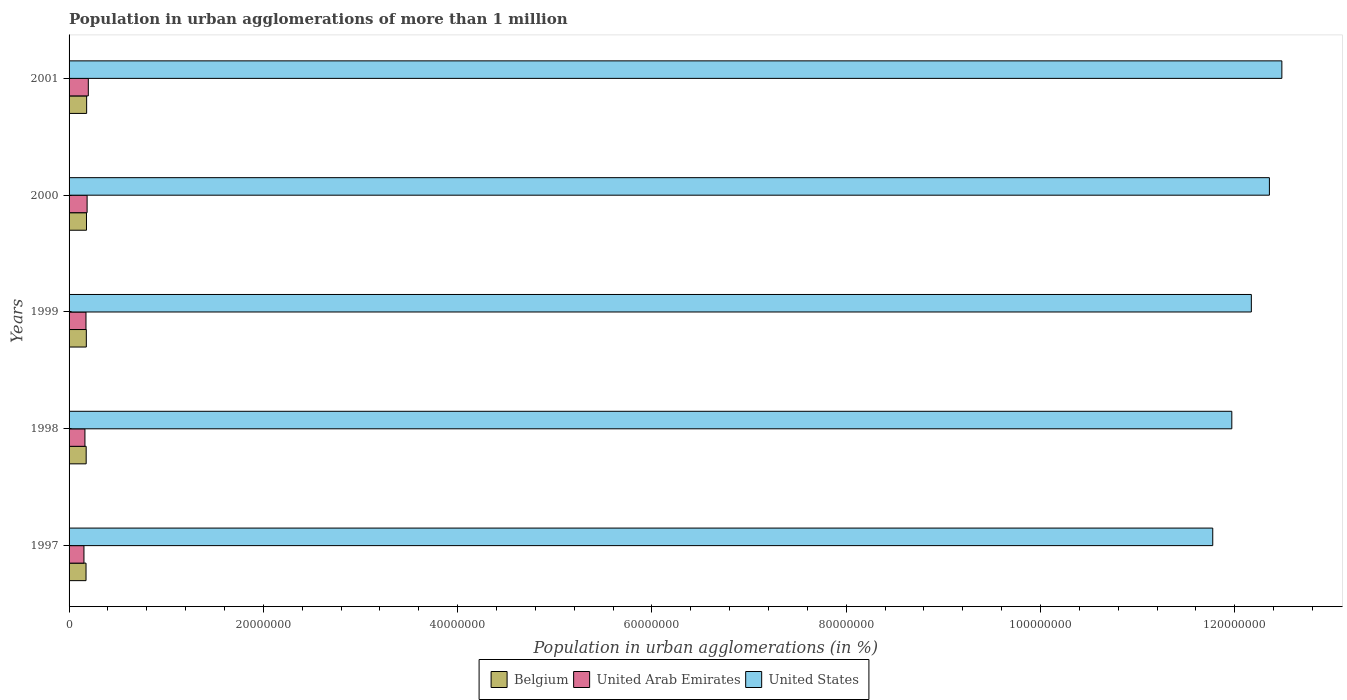How many different coloured bars are there?
Provide a succinct answer. 3. How many groups of bars are there?
Provide a short and direct response. 5. How many bars are there on the 2nd tick from the bottom?
Your answer should be very brief. 3. What is the label of the 1st group of bars from the top?
Keep it short and to the point. 2001. In how many cases, is the number of bars for a given year not equal to the number of legend labels?
Offer a terse response. 0. What is the population in urban agglomerations in Belgium in 1999?
Offer a terse response. 1.78e+06. Across all years, what is the maximum population in urban agglomerations in United States?
Make the answer very short. 1.25e+08. Across all years, what is the minimum population in urban agglomerations in United Arab Emirates?
Give a very brief answer. 1.53e+06. In which year was the population in urban agglomerations in Belgium minimum?
Your answer should be very brief. 1997. What is the total population in urban agglomerations in Belgium in the graph?
Offer a very short reply. 8.88e+06. What is the difference between the population in urban agglomerations in United Arab Emirates in 1998 and that in 2000?
Your answer should be compact. -2.24e+05. What is the difference between the population in urban agglomerations in United Arab Emirates in 2000 and the population in urban agglomerations in United States in 1999?
Your answer should be very brief. -1.20e+08. What is the average population in urban agglomerations in Belgium per year?
Your answer should be very brief. 1.78e+06. In the year 1999, what is the difference between the population in urban agglomerations in United Arab Emirates and population in urban agglomerations in Belgium?
Give a very brief answer. -3.55e+04. What is the ratio of the population in urban agglomerations in Belgium in 1998 to that in 2000?
Give a very brief answer. 0.98. Is the population in urban agglomerations in Belgium in 1997 less than that in 2000?
Make the answer very short. Yes. Is the difference between the population in urban agglomerations in United Arab Emirates in 1997 and 1998 greater than the difference between the population in urban agglomerations in Belgium in 1997 and 1998?
Offer a very short reply. No. What is the difference between the highest and the second highest population in urban agglomerations in United Arab Emirates?
Offer a very short reply. 1.23e+05. What is the difference between the highest and the lowest population in urban agglomerations in United States?
Your answer should be very brief. 7.11e+06. How many bars are there?
Ensure brevity in your answer.  15. What is the difference between two consecutive major ticks on the X-axis?
Offer a very short reply. 2.00e+07. Does the graph contain any zero values?
Your answer should be compact. No. Does the graph contain grids?
Provide a succinct answer. No. Where does the legend appear in the graph?
Your response must be concise. Bottom center. How are the legend labels stacked?
Keep it short and to the point. Horizontal. What is the title of the graph?
Keep it short and to the point. Population in urban agglomerations of more than 1 million. Does "Nepal" appear as one of the legend labels in the graph?
Your answer should be very brief. No. What is the label or title of the X-axis?
Provide a short and direct response. Population in urban agglomerations (in %). What is the label or title of the Y-axis?
Your answer should be very brief. Years. What is the Population in urban agglomerations (in %) in Belgium in 1997?
Ensure brevity in your answer.  1.75e+06. What is the Population in urban agglomerations (in %) in United Arab Emirates in 1997?
Offer a very short reply. 1.53e+06. What is the Population in urban agglomerations (in %) of United States in 1997?
Provide a short and direct response. 1.18e+08. What is the Population in urban agglomerations (in %) of Belgium in 1998?
Your answer should be compact. 1.76e+06. What is the Population in urban agglomerations (in %) of United Arab Emirates in 1998?
Provide a succinct answer. 1.63e+06. What is the Population in urban agglomerations (in %) in United States in 1998?
Offer a very short reply. 1.20e+08. What is the Population in urban agglomerations (in %) of Belgium in 1999?
Provide a succinct answer. 1.78e+06. What is the Population in urban agglomerations (in %) in United Arab Emirates in 1999?
Your response must be concise. 1.74e+06. What is the Population in urban agglomerations (in %) in United States in 1999?
Provide a short and direct response. 1.22e+08. What is the Population in urban agglomerations (in %) in Belgium in 2000?
Give a very brief answer. 1.79e+06. What is the Population in urban agglomerations (in %) of United Arab Emirates in 2000?
Provide a short and direct response. 1.86e+06. What is the Population in urban agglomerations (in %) of United States in 2000?
Keep it short and to the point. 1.24e+08. What is the Population in urban agglomerations (in %) of Belgium in 2001?
Your answer should be very brief. 1.81e+06. What is the Population in urban agglomerations (in %) in United Arab Emirates in 2001?
Your answer should be very brief. 1.98e+06. What is the Population in urban agglomerations (in %) of United States in 2001?
Your answer should be compact. 1.25e+08. Across all years, what is the maximum Population in urban agglomerations (in %) of Belgium?
Ensure brevity in your answer.  1.81e+06. Across all years, what is the maximum Population in urban agglomerations (in %) in United Arab Emirates?
Offer a very short reply. 1.98e+06. Across all years, what is the maximum Population in urban agglomerations (in %) in United States?
Your answer should be very brief. 1.25e+08. Across all years, what is the minimum Population in urban agglomerations (in %) of Belgium?
Your answer should be very brief. 1.75e+06. Across all years, what is the minimum Population in urban agglomerations (in %) of United Arab Emirates?
Your response must be concise. 1.53e+06. Across all years, what is the minimum Population in urban agglomerations (in %) in United States?
Provide a short and direct response. 1.18e+08. What is the total Population in urban agglomerations (in %) of Belgium in the graph?
Offer a very short reply. 8.88e+06. What is the total Population in urban agglomerations (in %) of United Arab Emirates in the graph?
Provide a short and direct response. 8.74e+06. What is the total Population in urban agglomerations (in %) of United States in the graph?
Provide a succinct answer. 6.08e+08. What is the difference between the Population in urban agglomerations (in %) in Belgium in 1997 and that in 1998?
Provide a succinct answer. -1.55e+04. What is the difference between the Population in urban agglomerations (in %) of United Arab Emirates in 1997 and that in 1998?
Your response must be concise. -1.01e+05. What is the difference between the Population in urban agglomerations (in %) in United States in 1997 and that in 1998?
Keep it short and to the point. -1.96e+06. What is the difference between the Population in urban agglomerations (in %) of Belgium in 1997 and that in 1999?
Offer a terse response. -3.11e+04. What is the difference between the Population in urban agglomerations (in %) in United Arab Emirates in 1997 and that in 1999?
Your response must be concise. -2.10e+05. What is the difference between the Population in urban agglomerations (in %) in United States in 1997 and that in 1999?
Offer a very short reply. -3.97e+06. What is the difference between the Population in urban agglomerations (in %) of Belgium in 1997 and that in 2000?
Give a very brief answer. -4.69e+04. What is the difference between the Population in urban agglomerations (in %) of United Arab Emirates in 1997 and that in 2000?
Offer a very short reply. -3.25e+05. What is the difference between the Population in urban agglomerations (in %) of United States in 1997 and that in 2000?
Provide a short and direct response. -5.83e+06. What is the difference between the Population in urban agglomerations (in %) of Belgium in 1997 and that in 2001?
Your response must be concise. -6.28e+04. What is the difference between the Population in urban agglomerations (in %) in United Arab Emirates in 1997 and that in 2001?
Make the answer very short. -4.49e+05. What is the difference between the Population in urban agglomerations (in %) in United States in 1997 and that in 2001?
Your answer should be compact. -7.11e+06. What is the difference between the Population in urban agglomerations (in %) in Belgium in 1998 and that in 1999?
Your answer should be very brief. -1.56e+04. What is the difference between the Population in urban agglomerations (in %) in United Arab Emirates in 1998 and that in 1999?
Give a very brief answer. -1.08e+05. What is the difference between the Population in urban agglomerations (in %) of United States in 1998 and that in 1999?
Make the answer very short. -2.01e+06. What is the difference between the Population in urban agglomerations (in %) of Belgium in 1998 and that in 2000?
Your answer should be compact. -3.14e+04. What is the difference between the Population in urban agglomerations (in %) in United Arab Emirates in 1998 and that in 2000?
Provide a short and direct response. -2.24e+05. What is the difference between the Population in urban agglomerations (in %) in United States in 1998 and that in 2000?
Your answer should be compact. -3.87e+06. What is the difference between the Population in urban agglomerations (in %) in Belgium in 1998 and that in 2001?
Offer a terse response. -4.73e+04. What is the difference between the Population in urban agglomerations (in %) of United Arab Emirates in 1998 and that in 2001?
Offer a very short reply. -3.47e+05. What is the difference between the Population in urban agglomerations (in %) of United States in 1998 and that in 2001?
Your answer should be compact. -5.15e+06. What is the difference between the Population in urban agglomerations (in %) in Belgium in 1999 and that in 2000?
Provide a short and direct response. -1.58e+04. What is the difference between the Population in urban agglomerations (in %) of United Arab Emirates in 1999 and that in 2000?
Make the answer very short. -1.16e+05. What is the difference between the Population in urban agglomerations (in %) in United States in 1999 and that in 2000?
Offer a terse response. -1.86e+06. What is the difference between the Population in urban agglomerations (in %) in Belgium in 1999 and that in 2001?
Your answer should be compact. -3.17e+04. What is the difference between the Population in urban agglomerations (in %) of United Arab Emirates in 1999 and that in 2001?
Keep it short and to the point. -2.39e+05. What is the difference between the Population in urban agglomerations (in %) in United States in 1999 and that in 2001?
Offer a terse response. -3.14e+06. What is the difference between the Population in urban agglomerations (in %) of Belgium in 2000 and that in 2001?
Keep it short and to the point. -1.59e+04. What is the difference between the Population in urban agglomerations (in %) in United Arab Emirates in 2000 and that in 2001?
Keep it short and to the point. -1.23e+05. What is the difference between the Population in urban agglomerations (in %) of United States in 2000 and that in 2001?
Offer a terse response. -1.28e+06. What is the difference between the Population in urban agglomerations (in %) of Belgium in 1997 and the Population in urban agglomerations (in %) of United Arab Emirates in 1998?
Make the answer very short. 1.13e+05. What is the difference between the Population in urban agglomerations (in %) of Belgium in 1997 and the Population in urban agglomerations (in %) of United States in 1998?
Your answer should be compact. -1.18e+08. What is the difference between the Population in urban agglomerations (in %) of United Arab Emirates in 1997 and the Population in urban agglomerations (in %) of United States in 1998?
Provide a succinct answer. -1.18e+08. What is the difference between the Population in urban agglomerations (in %) of Belgium in 1997 and the Population in urban agglomerations (in %) of United Arab Emirates in 1999?
Keep it short and to the point. 4359. What is the difference between the Population in urban agglomerations (in %) of Belgium in 1997 and the Population in urban agglomerations (in %) of United States in 1999?
Make the answer very short. -1.20e+08. What is the difference between the Population in urban agglomerations (in %) of United Arab Emirates in 1997 and the Population in urban agglomerations (in %) of United States in 1999?
Your answer should be very brief. -1.20e+08. What is the difference between the Population in urban agglomerations (in %) in Belgium in 1997 and the Population in urban agglomerations (in %) in United Arab Emirates in 2000?
Your answer should be compact. -1.11e+05. What is the difference between the Population in urban agglomerations (in %) of Belgium in 1997 and the Population in urban agglomerations (in %) of United States in 2000?
Provide a succinct answer. -1.22e+08. What is the difference between the Population in urban agglomerations (in %) in United Arab Emirates in 1997 and the Population in urban agglomerations (in %) in United States in 2000?
Your response must be concise. -1.22e+08. What is the difference between the Population in urban agglomerations (in %) in Belgium in 1997 and the Population in urban agglomerations (in %) in United Arab Emirates in 2001?
Give a very brief answer. -2.34e+05. What is the difference between the Population in urban agglomerations (in %) of Belgium in 1997 and the Population in urban agglomerations (in %) of United States in 2001?
Ensure brevity in your answer.  -1.23e+08. What is the difference between the Population in urban agglomerations (in %) in United Arab Emirates in 1997 and the Population in urban agglomerations (in %) in United States in 2001?
Make the answer very short. -1.23e+08. What is the difference between the Population in urban agglomerations (in %) of Belgium in 1998 and the Population in urban agglomerations (in %) of United Arab Emirates in 1999?
Keep it short and to the point. 1.99e+04. What is the difference between the Population in urban agglomerations (in %) of Belgium in 1998 and the Population in urban agglomerations (in %) of United States in 1999?
Keep it short and to the point. -1.20e+08. What is the difference between the Population in urban agglomerations (in %) of United Arab Emirates in 1998 and the Population in urban agglomerations (in %) of United States in 1999?
Ensure brevity in your answer.  -1.20e+08. What is the difference between the Population in urban agglomerations (in %) of Belgium in 1998 and the Population in urban agglomerations (in %) of United Arab Emirates in 2000?
Offer a very short reply. -9.58e+04. What is the difference between the Population in urban agglomerations (in %) in Belgium in 1998 and the Population in urban agglomerations (in %) in United States in 2000?
Your answer should be compact. -1.22e+08. What is the difference between the Population in urban agglomerations (in %) in United Arab Emirates in 1998 and the Population in urban agglomerations (in %) in United States in 2000?
Provide a succinct answer. -1.22e+08. What is the difference between the Population in urban agglomerations (in %) of Belgium in 1998 and the Population in urban agglomerations (in %) of United Arab Emirates in 2001?
Offer a very short reply. -2.19e+05. What is the difference between the Population in urban agglomerations (in %) in Belgium in 1998 and the Population in urban agglomerations (in %) in United States in 2001?
Provide a succinct answer. -1.23e+08. What is the difference between the Population in urban agglomerations (in %) of United Arab Emirates in 1998 and the Population in urban agglomerations (in %) of United States in 2001?
Provide a succinct answer. -1.23e+08. What is the difference between the Population in urban agglomerations (in %) of Belgium in 1999 and the Population in urban agglomerations (in %) of United Arab Emirates in 2000?
Provide a succinct answer. -8.02e+04. What is the difference between the Population in urban agglomerations (in %) in Belgium in 1999 and the Population in urban agglomerations (in %) in United States in 2000?
Provide a short and direct response. -1.22e+08. What is the difference between the Population in urban agglomerations (in %) of United Arab Emirates in 1999 and the Population in urban agglomerations (in %) of United States in 2000?
Make the answer very short. -1.22e+08. What is the difference between the Population in urban agglomerations (in %) of Belgium in 1999 and the Population in urban agglomerations (in %) of United Arab Emirates in 2001?
Provide a short and direct response. -2.03e+05. What is the difference between the Population in urban agglomerations (in %) in Belgium in 1999 and the Population in urban agglomerations (in %) in United States in 2001?
Offer a very short reply. -1.23e+08. What is the difference between the Population in urban agglomerations (in %) of United Arab Emirates in 1999 and the Population in urban agglomerations (in %) of United States in 2001?
Offer a terse response. -1.23e+08. What is the difference between the Population in urban agglomerations (in %) of Belgium in 2000 and the Population in urban agglomerations (in %) of United Arab Emirates in 2001?
Offer a very short reply. -1.88e+05. What is the difference between the Population in urban agglomerations (in %) of Belgium in 2000 and the Population in urban agglomerations (in %) of United States in 2001?
Give a very brief answer. -1.23e+08. What is the difference between the Population in urban agglomerations (in %) in United Arab Emirates in 2000 and the Population in urban agglomerations (in %) in United States in 2001?
Provide a short and direct response. -1.23e+08. What is the average Population in urban agglomerations (in %) in Belgium per year?
Ensure brevity in your answer.  1.78e+06. What is the average Population in urban agglomerations (in %) in United Arab Emirates per year?
Ensure brevity in your answer.  1.75e+06. What is the average Population in urban agglomerations (in %) of United States per year?
Offer a very short reply. 1.22e+08. In the year 1997, what is the difference between the Population in urban agglomerations (in %) in Belgium and Population in urban agglomerations (in %) in United Arab Emirates?
Offer a terse response. 2.14e+05. In the year 1997, what is the difference between the Population in urban agglomerations (in %) in Belgium and Population in urban agglomerations (in %) in United States?
Give a very brief answer. -1.16e+08. In the year 1997, what is the difference between the Population in urban agglomerations (in %) of United Arab Emirates and Population in urban agglomerations (in %) of United States?
Offer a terse response. -1.16e+08. In the year 1998, what is the difference between the Population in urban agglomerations (in %) of Belgium and Population in urban agglomerations (in %) of United Arab Emirates?
Offer a very short reply. 1.28e+05. In the year 1998, what is the difference between the Population in urban agglomerations (in %) in Belgium and Population in urban agglomerations (in %) in United States?
Keep it short and to the point. -1.18e+08. In the year 1998, what is the difference between the Population in urban agglomerations (in %) in United Arab Emirates and Population in urban agglomerations (in %) in United States?
Ensure brevity in your answer.  -1.18e+08. In the year 1999, what is the difference between the Population in urban agglomerations (in %) in Belgium and Population in urban agglomerations (in %) in United Arab Emirates?
Give a very brief answer. 3.55e+04. In the year 1999, what is the difference between the Population in urban agglomerations (in %) in Belgium and Population in urban agglomerations (in %) in United States?
Provide a short and direct response. -1.20e+08. In the year 1999, what is the difference between the Population in urban agglomerations (in %) in United Arab Emirates and Population in urban agglomerations (in %) in United States?
Ensure brevity in your answer.  -1.20e+08. In the year 2000, what is the difference between the Population in urban agglomerations (in %) of Belgium and Population in urban agglomerations (in %) of United Arab Emirates?
Your response must be concise. -6.44e+04. In the year 2000, what is the difference between the Population in urban agglomerations (in %) in Belgium and Population in urban agglomerations (in %) in United States?
Keep it short and to the point. -1.22e+08. In the year 2000, what is the difference between the Population in urban agglomerations (in %) in United Arab Emirates and Population in urban agglomerations (in %) in United States?
Provide a short and direct response. -1.22e+08. In the year 2001, what is the difference between the Population in urban agglomerations (in %) in Belgium and Population in urban agglomerations (in %) in United Arab Emirates?
Offer a very short reply. -1.72e+05. In the year 2001, what is the difference between the Population in urban agglomerations (in %) in Belgium and Population in urban agglomerations (in %) in United States?
Ensure brevity in your answer.  -1.23e+08. In the year 2001, what is the difference between the Population in urban agglomerations (in %) of United Arab Emirates and Population in urban agglomerations (in %) of United States?
Make the answer very short. -1.23e+08. What is the ratio of the Population in urban agglomerations (in %) of Belgium in 1997 to that in 1998?
Keep it short and to the point. 0.99. What is the ratio of the Population in urban agglomerations (in %) in United Arab Emirates in 1997 to that in 1998?
Your response must be concise. 0.94. What is the ratio of the Population in urban agglomerations (in %) of United States in 1997 to that in 1998?
Your answer should be very brief. 0.98. What is the ratio of the Population in urban agglomerations (in %) of Belgium in 1997 to that in 1999?
Provide a short and direct response. 0.98. What is the ratio of the Population in urban agglomerations (in %) in United Arab Emirates in 1997 to that in 1999?
Your answer should be compact. 0.88. What is the ratio of the Population in urban agglomerations (in %) of United States in 1997 to that in 1999?
Give a very brief answer. 0.97. What is the ratio of the Population in urban agglomerations (in %) of Belgium in 1997 to that in 2000?
Offer a terse response. 0.97. What is the ratio of the Population in urban agglomerations (in %) of United Arab Emirates in 1997 to that in 2000?
Offer a very short reply. 0.82. What is the ratio of the Population in urban agglomerations (in %) in United States in 1997 to that in 2000?
Offer a very short reply. 0.95. What is the ratio of the Population in urban agglomerations (in %) of Belgium in 1997 to that in 2001?
Provide a succinct answer. 0.97. What is the ratio of the Population in urban agglomerations (in %) of United Arab Emirates in 1997 to that in 2001?
Offer a very short reply. 0.77. What is the ratio of the Population in urban agglomerations (in %) in United States in 1997 to that in 2001?
Ensure brevity in your answer.  0.94. What is the ratio of the Population in urban agglomerations (in %) of Belgium in 1998 to that in 1999?
Give a very brief answer. 0.99. What is the ratio of the Population in urban agglomerations (in %) in United Arab Emirates in 1998 to that in 1999?
Your answer should be compact. 0.94. What is the ratio of the Population in urban agglomerations (in %) of United States in 1998 to that in 1999?
Make the answer very short. 0.98. What is the ratio of the Population in urban agglomerations (in %) of Belgium in 1998 to that in 2000?
Give a very brief answer. 0.98. What is the ratio of the Population in urban agglomerations (in %) of United Arab Emirates in 1998 to that in 2000?
Your response must be concise. 0.88. What is the ratio of the Population in urban agglomerations (in %) of United States in 1998 to that in 2000?
Your response must be concise. 0.97. What is the ratio of the Population in urban agglomerations (in %) of Belgium in 1998 to that in 2001?
Offer a very short reply. 0.97. What is the ratio of the Population in urban agglomerations (in %) of United Arab Emirates in 1998 to that in 2001?
Provide a succinct answer. 0.82. What is the ratio of the Population in urban agglomerations (in %) of United States in 1998 to that in 2001?
Give a very brief answer. 0.96. What is the ratio of the Population in urban agglomerations (in %) in United Arab Emirates in 1999 to that in 2000?
Give a very brief answer. 0.94. What is the ratio of the Population in urban agglomerations (in %) of United States in 1999 to that in 2000?
Keep it short and to the point. 0.98. What is the ratio of the Population in urban agglomerations (in %) in Belgium in 1999 to that in 2001?
Your answer should be very brief. 0.98. What is the ratio of the Population in urban agglomerations (in %) of United Arab Emirates in 1999 to that in 2001?
Your answer should be compact. 0.88. What is the ratio of the Population in urban agglomerations (in %) in United States in 1999 to that in 2001?
Make the answer very short. 0.97. What is the ratio of the Population in urban agglomerations (in %) of Belgium in 2000 to that in 2001?
Offer a very short reply. 0.99. What is the ratio of the Population in urban agglomerations (in %) of United Arab Emirates in 2000 to that in 2001?
Offer a very short reply. 0.94. What is the difference between the highest and the second highest Population in urban agglomerations (in %) in Belgium?
Offer a terse response. 1.59e+04. What is the difference between the highest and the second highest Population in urban agglomerations (in %) of United Arab Emirates?
Offer a very short reply. 1.23e+05. What is the difference between the highest and the second highest Population in urban agglomerations (in %) in United States?
Make the answer very short. 1.28e+06. What is the difference between the highest and the lowest Population in urban agglomerations (in %) of Belgium?
Offer a terse response. 6.28e+04. What is the difference between the highest and the lowest Population in urban agglomerations (in %) of United Arab Emirates?
Your response must be concise. 4.49e+05. What is the difference between the highest and the lowest Population in urban agglomerations (in %) in United States?
Your answer should be very brief. 7.11e+06. 